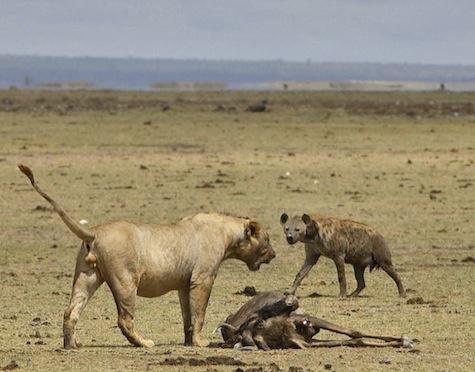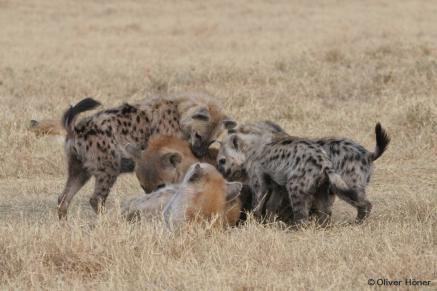The first image is the image on the left, the second image is the image on the right. Assess this claim about the two images: "The right image includes at least one jackal near at least two spotted hyenas.". Correct or not? Answer yes or no. No. 